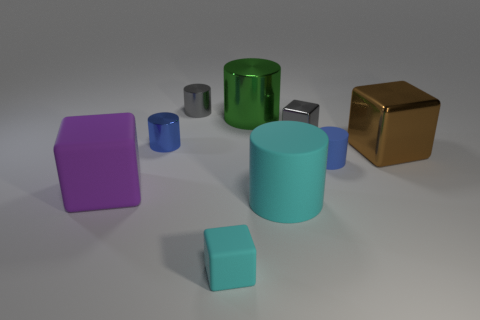Subtract all blocks. How many objects are left? 5 Add 1 cyan metallic blocks. How many objects exist? 10 Subtract all green cylinders. How many cylinders are left? 4 Subtract all blue matte cylinders. How many cylinders are left? 4 Subtract 0 red cylinders. How many objects are left? 9 Subtract 1 blocks. How many blocks are left? 3 Subtract all purple cylinders. Subtract all red balls. How many cylinders are left? 5 Subtract all cyan cylinders. How many brown blocks are left? 1 Subtract all small matte blocks. Subtract all blue rubber things. How many objects are left? 7 Add 2 rubber cubes. How many rubber cubes are left? 4 